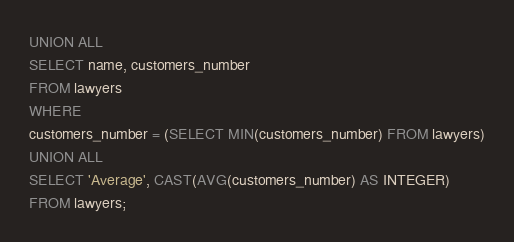Convert code to text. <code><loc_0><loc_0><loc_500><loc_500><_SQL_>UNION ALL
SELECT name, customers_number
FROM lawyers
WHERE
customers_number = (SELECT MIN(customers_number) FROM lawyers)
UNION ALL
SELECT 'Average', CAST(AVG(customers_number) AS INTEGER)
FROM lawyers;</code> 